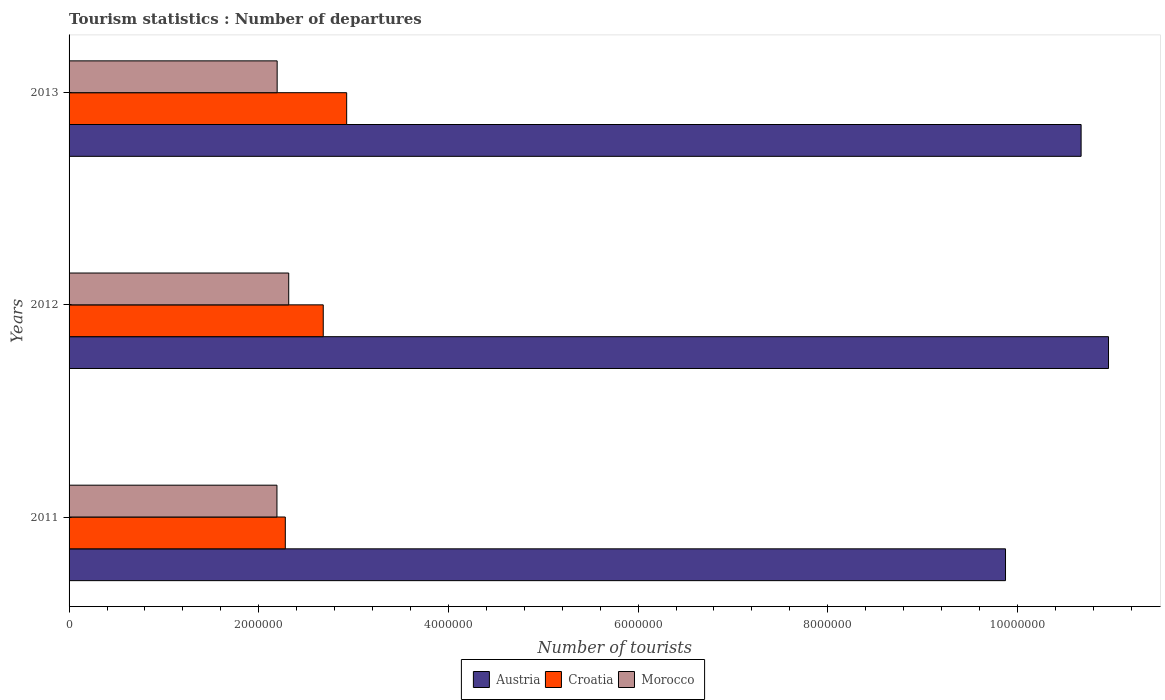How many different coloured bars are there?
Ensure brevity in your answer.  3. Are the number of bars per tick equal to the number of legend labels?
Provide a succinct answer. Yes. How many bars are there on the 2nd tick from the top?
Your response must be concise. 3. What is the label of the 2nd group of bars from the top?
Make the answer very short. 2012. What is the number of tourist departures in Austria in 2011?
Provide a succinct answer. 9.87e+06. Across all years, what is the maximum number of tourist departures in Austria?
Give a very brief answer. 1.10e+07. Across all years, what is the minimum number of tourist departures in Austria?
Provide a succinct answer. 9.87e+06. In which year was the number of tourist departures in Austria maximum?
Ensure brevity in your answer.  2012. In which year was the number of tourist departures in Morocco minimum?
Provide a succinct answer. 2011. What is the total number of tourist departures in Austria in the graph?
Offer a terse response. 3.15e+07. What is the difference between the number of tourist departures in Croatia in 2012 and that in 2013?
Offer a terse response. -2.47e+05. What is the difference between the number of tourist departures in Austria in 2011 and the number of tourist departures in Croatia in 2013?
Ensure brevity in your answer.  6.95e+06. What is the average number of tourist departures in Austria per year?
Offer a terse response. 1.05e+07. In the year 2011, what is the difference between the number of tourist departures in Croatia and number of tourist departures in Austria?
Your answer should be very brief. -7.59e+06. In how many years, is the number of tourist departures in Austria greater than 5200000 ?
Your response must be concise. 3. What is the ratio of the number of tourist departures in Morocco in 2011 to that in 2012?
Make the answer very short. 0.95. What is the difference between the highest and the second highest number of tourist departures in Morocco?
Offer a very short reply. 1.22e+05. What is the difference between the highest and the lowest number of tourist departures in Croatia?
Keep it short and to the point. 6.47e+05. Is the sum of the number of tourist departures in Croatia in 2011 and 2013 greater than the maximum number of tourist departures in Morocco across all years?
Your response must be concise. Yes. What does the 1st bar from the bottom in 2013 represents?
Offer a very short reply. Austria. How many bars are there?
Your answer should be compact. 9. What is the difference between two consecutive major ticks on the X-axis?
Make the answer very short. 2.00e+06. How many legend labels are there?
Provide a short and direct response. 3. What is the title of the graph?
Give a very brief answer. Tourism statistics : Number of departures. What is the label or title of the X-axis?
Your response must be concise. Number of tourists. What is the label or title of the Y-axis?
Provide a short and direct response. Years. What is the Number of tourists in Austria in 2011?
Your answer should be very brief. 9.87e+06. What is the Number of tourists of Croatia in 2011?
Give a very brief answer. 2.28e+06. What is the Number of tourists of Morocco in 2011?
Offer a terse response. 2.19e+06. What is the Number of tourists of Austria in 2012?
Make the answer very short. 1.10e+07. What is the Number of tourists in Croatia in 2012?
Give a very brief answer. 2.68e+06. What is the Number of tourists of Morocco in 2012?
Provide a short and direct response. 2.32e+06. What is the Number of tourists of Austria in 2013?
Your response must be concise. 1.07e+07. What is the Number of tourists in Croatia in 2013?
Your answer should be very brief. 2.93e+06. What is the Number of tourists in Morocco in 2013?
Give a very brief answer. 2.19e+06. Across all years, what is the maximum Number of tourists of Austria?
Offer a very short reply. 1.10e+07. Across all years, what is the maximum Number of tourists of Croatia?
Provide a succinct answer. 2.93e+06. Across all years, what is the maximum Number of tourists of Morocco?
Offer a very short reply. 2.32e+06. Across all years, what is the minimum Number of tourists of Austria?
Offer a very short reply. 9.87e+06. Across all years, what is the minimum Number of tourists in Croatia?
Your answer should be very brief. 2.28e+06. Across all years, what is the minimum Number of tourists in Morocco?
Give a very brief answer. 2.19e+06. What is the total Number of tourists in Austria in the graph?
Your response must be concise. 3.15e+07. What is the total Number of tourists of Croatia in the graph?
Give a very brief answer. 7.89e+06. What is the total Number of tourists of Morocco in the graph?
Your answer should be compact. 6.70e+06. What is the difference between the Number of tourists in Austria in 2011 and that in 2012?
Your answer should be compact. -1.09e+06. What is the difference between the Number of tourists in Croatia in 2011 and that in 2012?
Give a very brief answer. -4.00e+05. What is the difference between the Number of tourists in Morocco in 2011 and that in 2012?
Your response must be concise. -1.24e+05. What is the difference between the Number of tourists of Austria in 2011 and that in 2013?
Provide a short and direct response. -7.97e+05. What is the difference between the Number of tourists of Croatia in 2011 and that in 2013?
Make the answer very short. -6.47e+05. What is the difference between the Number of tourists of Morocco in 2011 and that in 2013?
Your answer should be very brief. -2000. What is the difference between the Number of tourists in Austria in 2012 and that in 2013?
Provide a short and direct response. 2.89e+05. What is the difference between the Number of tourists in Croatia in 2012 and that in 2013?
Your answer should be compact. -2.47e+05. What is the difference between the Number of tourists in Morocco in 2012 and that in 2013?
Offer a terse response. 1.22e+05. What is the difference between the Number of tourists in Austria in 2011 and the Number of tourists in Croatia in 2012?
Your answer should be very brief. 7.19e+06. What is the difference between the Number of tourists of Austria in 2011 and the Number of tourists of Morocco in 2012?
Provide a succinct answer. 7.56e+06. What is the difference between the Number of tourists in Croatia in 2011 and the Number of tourists in Morocco in 2012?
Offer a terse response. -3.60e+04. What is the difference between the Number of tourists in Austria in 2011 and the Number of tourists in Croatia in 2013?
Provide a short and direct response. 6.95e+06. What is the difference between the Number of tourists in Austria in 2011 and the Number of tourists in Morocco in 2013?
Offer a terse response. 7.68e+06. What is the difference between the Number of tourists in Croatia in 2011 and the Number of tourists in Morocco in 2013?
Keep it short and to the point. 8.60e+04. What is the difference between the Number of tourists of Austria in 2012 and the Number of tourists of Croatia in 2013?
Provide a short and direct response. 8.03e+06. What is the difference between the Number of tourists in Austria in 2012 and the Number of tourists in Morocco in 2013?
Ensure brevity in your answer.  8.77e+06. What is the difference between the Number of tourists in Croatia in 2012 and the Number of tourists in Morocco in 2013?
Make the answer very short. 4.86e+05. What is the average Number of tourists in Austria per year?
Ensure brevity in your answer.  1.05e+07. What is the average Number of tourists in Croatia per year?
Make the answer very short. 2.63e+06. What is the average Number of tourists in Morocco per year?
Your response must be concise. 2.23e+06. In the year 2011, what is the difference between the Number of tourists in Austria and Number of tourists in Croatia?
Make the answer very short. 7.59e+06. In the year 2011, what is the difference between the Number of tourists of Austria and Number of tourists of Morocco?
Ensure brevity in your answer.  7.68e+06. In the year 2011, what is the difference between the Number of tourists in Croatia and Number of tourists in Morocco?
Offer a terse response. 8.80e+04. In the year 2012, what is the difference between the Number of tourists in Austria and Number of tourists in Croatia?
Provide a short and direct response. 8.28e+06. In the year 2012, what is the difference between the Number of tourists of Austria and Number of tourists of Morocco?
Your answer should be very brief. 8.64e+06. In the year 2012, what is the difference between the Number of tourists in Croatia and Number of tourists in Morocco?
Your answer should be very brief. 3.64e+05. In the year 2013, what is the difference between the Number of tourists in Austria and Number of tourists in Croatia?
Offer a terse response. 7.74e+06. In the year 2013, what is the difference between the Number of tourists of Austria and Number of tourists of Morocco?
Make the answer very short. 8.48e+06. In the year 2013, what is the difference between the Number of tourists of Croatia and Number of tourists of Morocco?
Make the answer very short. 7.33e+05. What is the ratio of the Number of tourists in Austria in 2011 to that in 2012?
Make the answer very short. 0.9. What is the ratio of the Number of tourists of Croatia in 2011 to that in 2012?
Provide a succinct answer. 0.85. What is the ratio of the Number of tourists of Morocco in 2011 to that in 2012?
Your answer should be compact. 0.95. What is the ratio of the Number of tourists of Austria in 2011 to that in 2013?
Keep it short and to the point. 0.93. What is the ratio of the Number of tourists in Croatia in 2011 to that in 2013?
Provide a short and direct response. 0.78. What is the ratio of the Number of tourists in Morocco in 2011 to that in 2013?
Offer a terse response. 1. What is the ratio of the Number of tourists in Austria in 2012 to that in 2013?
Keep it short and to the point. 1.03. What is the ratio of the Number of tourists in Croatia in 2012 to that in 2013?
Provide a succinct answer. 0.92. What is the ratio of the Number of tourists in Morocco in 2012 to that in 2013?
Offer a very short reply. 1.06. What is the difference between the highest and the second highest Number of tourists of Austria?
Give a very brief answer. 2.89e+05. What is the difference between the highest and the second highest Number of tourists of Croatia?
Keep it short and to the point. 2.47e+05. What is the difference between the highest and the second highest Number of tourists of Morocco?
Keep it short and to the point. 1.22e+05. What is the difference between the highest and the lowest Number of tourists in Austria?
Your answer should be very brief. 1.09e+06. What is the difference between the highest and the lowest Number of tourists in Croatia?
Keep it short and to the point. 6.47e+05. What is the difference between the highest and the lowest Number of tourists in Morocco?
Ensure brevity in your answer.  1.24e+05. 